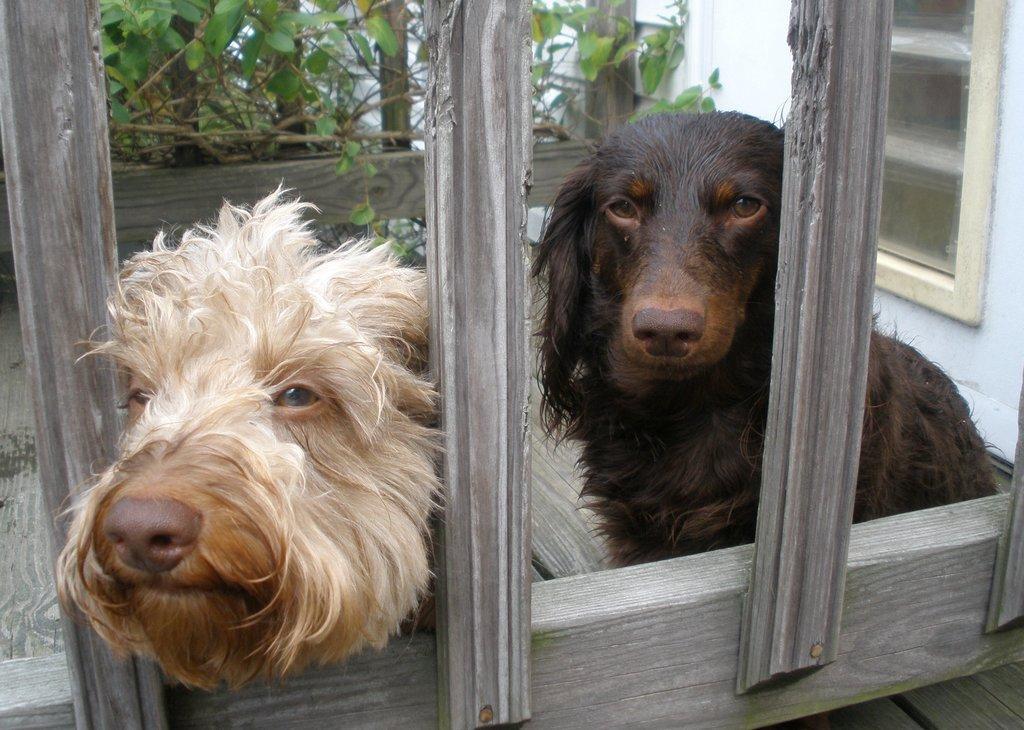In one or two sentences, can you explain what this image depicts? In this picture we can see there are two dogs and in front of the dogs, it looks like a wooden fence. Behind the dogs there are plants and a wall with a window. 